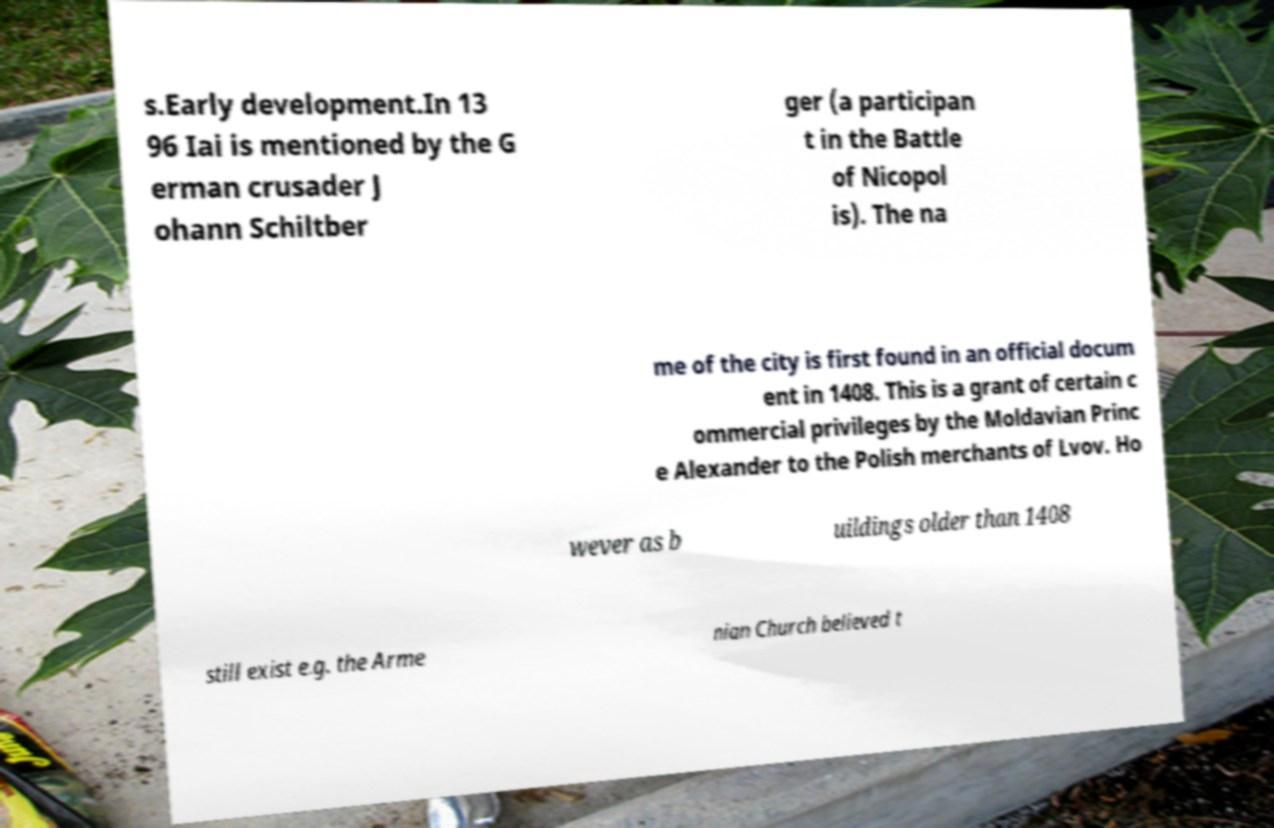There's text embedded in this image that I need extracted. Can you transcribe it verbatim? s.Early development.In 13 96 Iai is mentioned by the G erman crusader J ohann Schiltber ger (a participan t in the Battle of Nicopol is). The na me of the city is first found in an official docum ent in 1408. This is a grant of certain c ommercial privileges by the Moldavian Princ e Alexander to the Polish merchants of Lvov. Ho wever as b uildings older than 1408 still exist e.g. the Arme nian Church believed t 